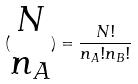Convert formula to latex. <formula><loc_0><loc_0><loc_500><loc_500>( \begin{matrix} N \\ n _ { A } \end{matrix} ) = \frac { N ! } { n _ { A } ! n _ { B } ! }</formula> 